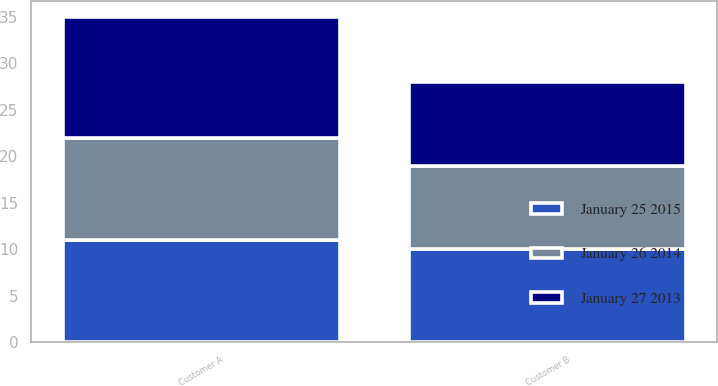Convert chart to OTSL. <chart><loc_0><loc_0><loc_500><loc_500><stacked_bar_chart><ecel><fcel>Customer A<fcel>Customer B<nl><fcel>January 26 2014<fcel>11<fcel>9<nl><fcel>January 25 2015<fcel>11<fcel>10<nl><fcel>January 27 2013<fcel>13<fcel>9<nl></chart> 